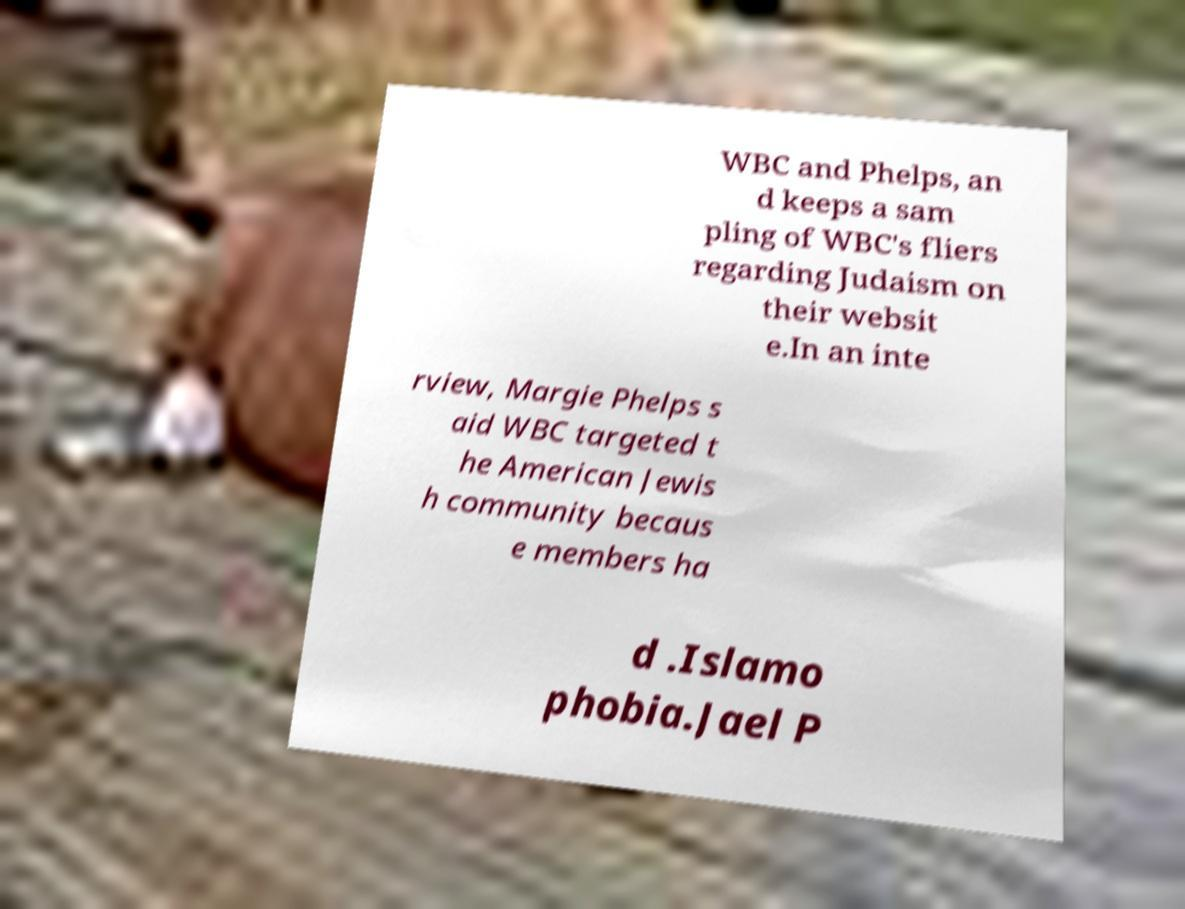Can you read and provide the text displayed in the image?This photo seems to have some interesting text. Can you extract and type it out for me? WBC and Phelps, an d keeps a sam pling of WBC's fliers regarding Judaism on their websit e.In an inte rview, Margie Phelps s aid WBC targeted t he American Jewis h community becaus e members ha d .Islamo phobia.Jael P 